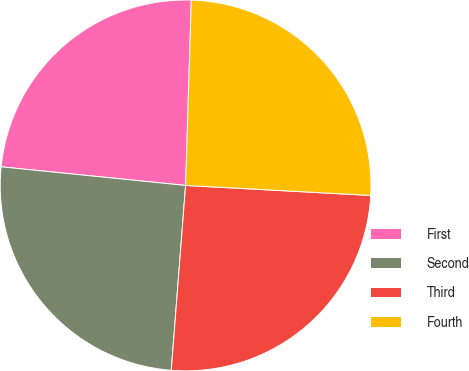<chart> <loc_0><loc_0><loc_500><loc_500><pie_chart><fcel>First<fcel>Second<fcel>Third<fcel>Fourth<nl><fcel>23.89%<fcel>25.37%<fcel>25.37%<fcel>25.37%<nl></chart> 